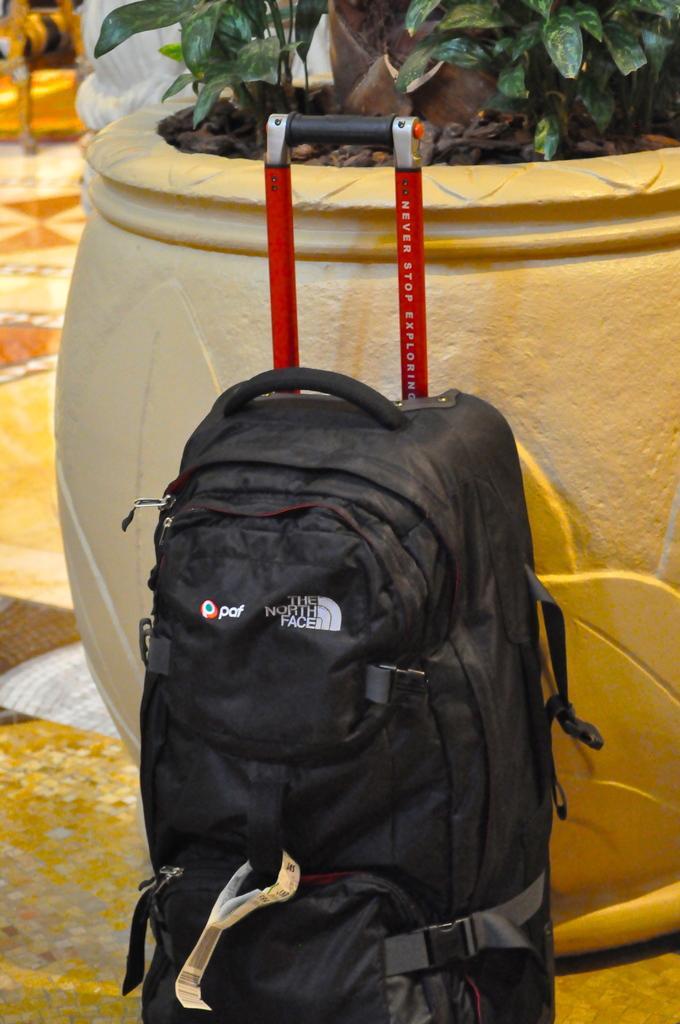Describe this image in one or two sentences. In the center we can see backpack,which is in black color. In the background there is a pot and plant. 